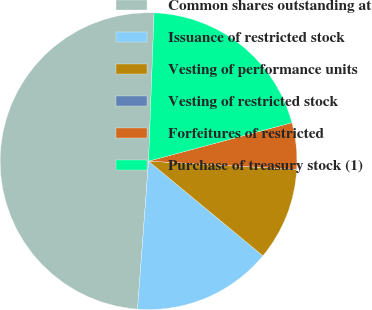<chart> <loc_0><loc_0><loc_500><loc_500><pie_chart><fcel>Common shares outstanding at<fcel>Issuance of restricted stock<fcel>Vesting of performance units<fcel>Vesting of restricted stock<fcel>Forfeitures of restricted<fcel>Purchase of treasury stock (1)<nl><fcel>49.41%<fcel>15.18%<fcel>10.12%<fcel>0.0%<fcel>5.06%<fcel>20.23%<nl></chart> 